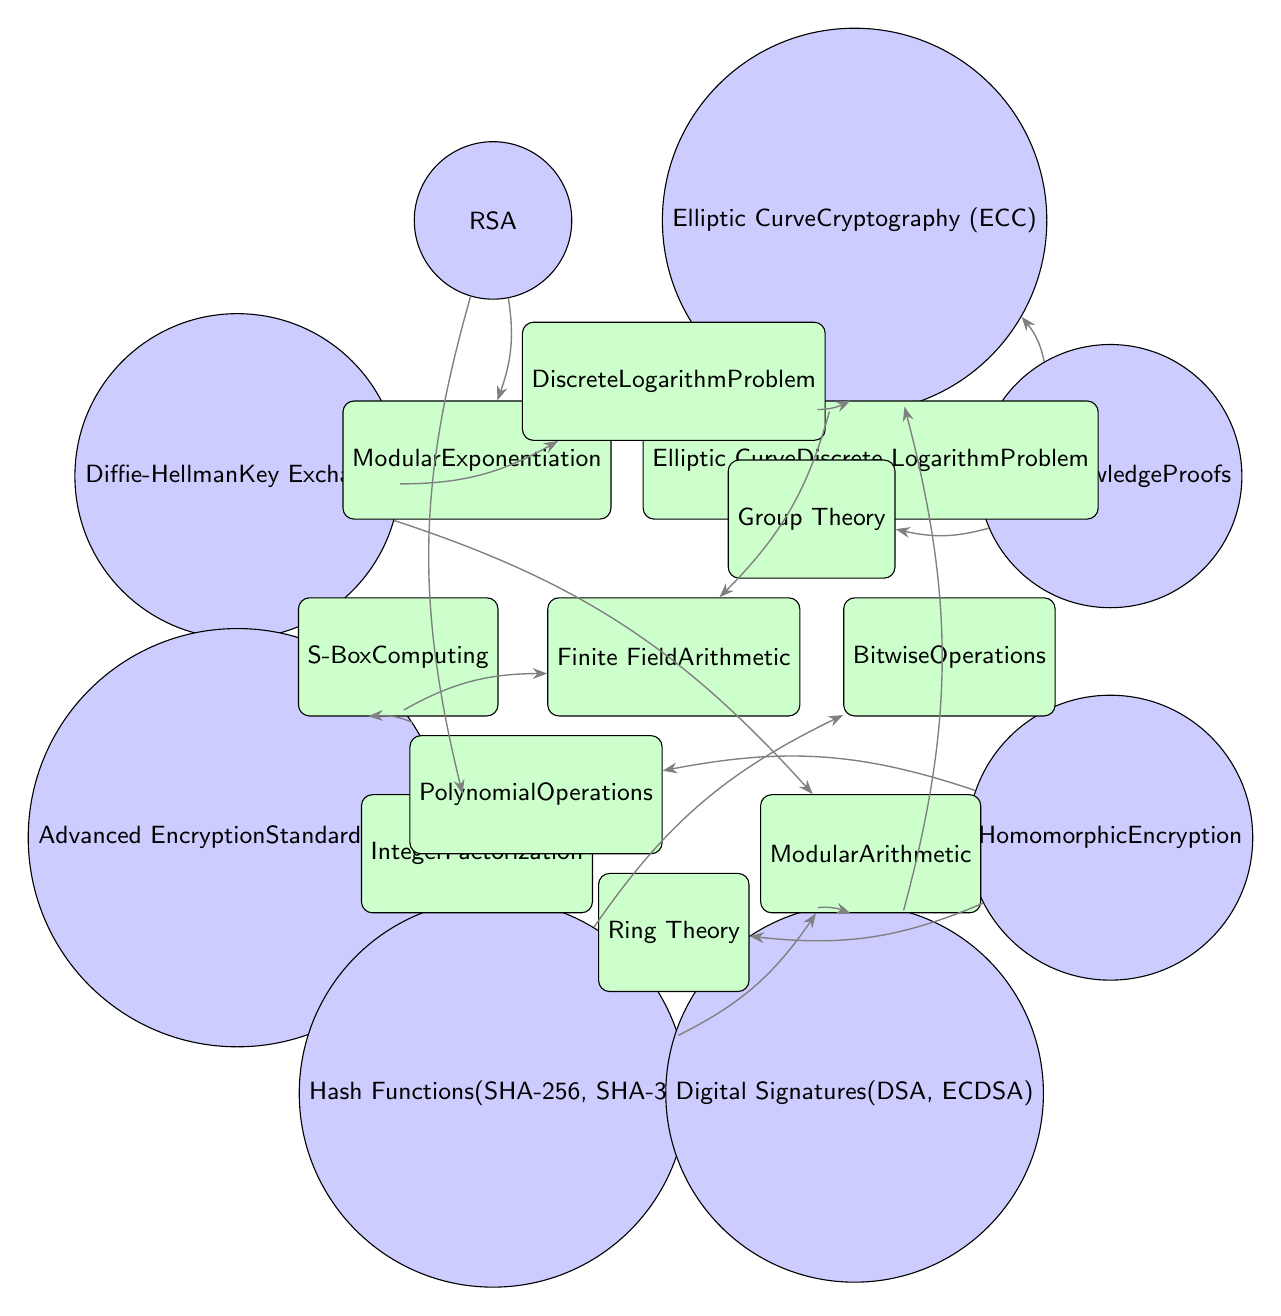What are the nodes representing the cryptographic protocols in the diagram? The nodes representing the cryptographic protocols are Elliptic Curve Cryptography, RSA, Diffie-Hellman Key Exchange, Advanced Encryption Standard, Hash Functions, Digital Signatures, Homomorphic Encryption, and Zero-Knowledge Proofs.
Answer: Elliptic Curve Cryptography, RSA, Diffie-Hellman Key Exchange, Advanced Encryption Standard, Hash Functions, Digital Signatures, Homomorphic Encryption, Zero-Knowledge Proofs How many dependencies does the Digital Signatures node have? The Digital Signatures node has two dependencies, which are Modular Arithmetic and Elliptic Curve Cryptography. This can be counted directly from the connections emanating from the Digital Signatures node.
Answer: 2 Which cryptographic protocol depends on the Ring Theory dependency? The Homomorphic Encryption protocol is the only one that depends on the Ring Theory dependency, as evidenced by following the arrow from the Homomorphic Encryption node to the Ring Theory node.
Answer: Homomorphic Encryption What are the dependencies of the Advanced Encryption Standard (AES)? The dependencies of the Advanced Encryption Standard node are Finite Field Arithmetic and S-Box Computing. These are indicated by the arrows connecting the AES node to its respective dependency nodes.
Answer: Finite Field Arithmetic, S-Box Computing What is the relationship between the Zero-Knowledge Proofs and Group Theory? The Zero-Knowledge Proofs node has a direct connection to the Group Theory dependency node, indicating that it relies on Group Theory as a fundamental concept in its implementation, as seen through the connecting arrow.
Answer: Depends on How many dependencies are shared between Elliptic Curve Cryptography and Digital Signatures? Elliptic Curve Cryptography and Digital Signatures share one dependency, which is Modular Arithmetic. This can be identified by analyzing the incoming connections to both nodes.
Answer: 1 Which dependency is connected to the Diffie-Hellman Key Exchange node? The dependencies connected to the Diffie-Hellman Key Exchange node are Modular Arithmetic and Discrete Logarithm Problem, as reflected by the arrows pointing from these dependency nodes to the Diffie-Hellman Key Exchange node.
Answer: Modular Arithmetic, Discrete Logarithm Problem What is the total number of elements (protocols and dependencies) in the diagram? To find the total number of elements, count both the protocol nodes and dependency nodes in the diagram. There are 8 protocol nodes and 11 dependency nodes, giving a total of 19 elements.
Answer: 19 